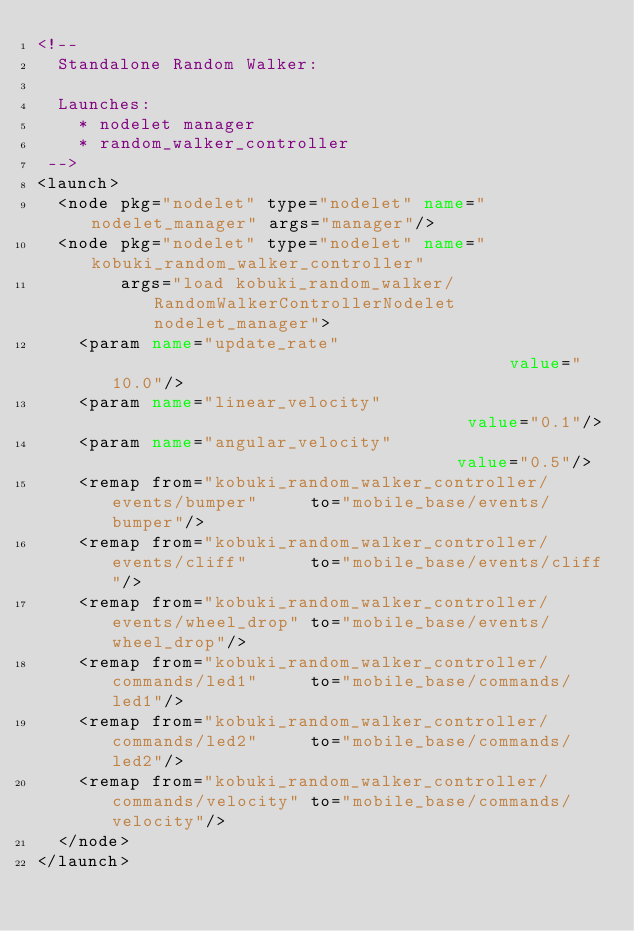<code> <loc_0><loc_0><loc_500><loc_500><_XML_><!--
  Standalone Random Walker:
  
  Launches:
    * nodelet manager
    * random_walker_controller
 -->
<launch>
  <node pkg="nodelet" type="nodelet" name="nodelet_manager" args="manager"/>
  <node pkg="nodelet" type="nodelet" name="kobuki_random_walker_controller"
        args="load kobuki_random_walker/RandomWalkerControllerNodelet nodelet_manager">
    <param name="update_rate"                                       value="10.0"/>
    <param name="linear_velocity"                                   value="0.1"/>
    <param name="angular_velocity"                                  value="0.5"/>
    <remap from="kobuki_random_walker_controller/events/bumper"     to="mobile_base/events/bumper"/>
    <remap from="kobuki_random_walker_controller/events/cliff"      to="mobile_base/events/cliff"/>
    <remap from="kobuki_random_walker_controller/events/wheel_drop" to="mobile_base/events/wheel_drop"/>
    <remap from="kobuki_random_walker_controller/commands/led1"     to="mobile_base/commands/led1"/>
    <remap from="kobuki_random_walker_controller/commands/led2"     to="mobile_base/commands/led2"/>
    <remap from="kobuki_random_walker_controller/commands/velocity" to="mobile_base/commands/velocity"/>
  </node>
</launch>
</code> 